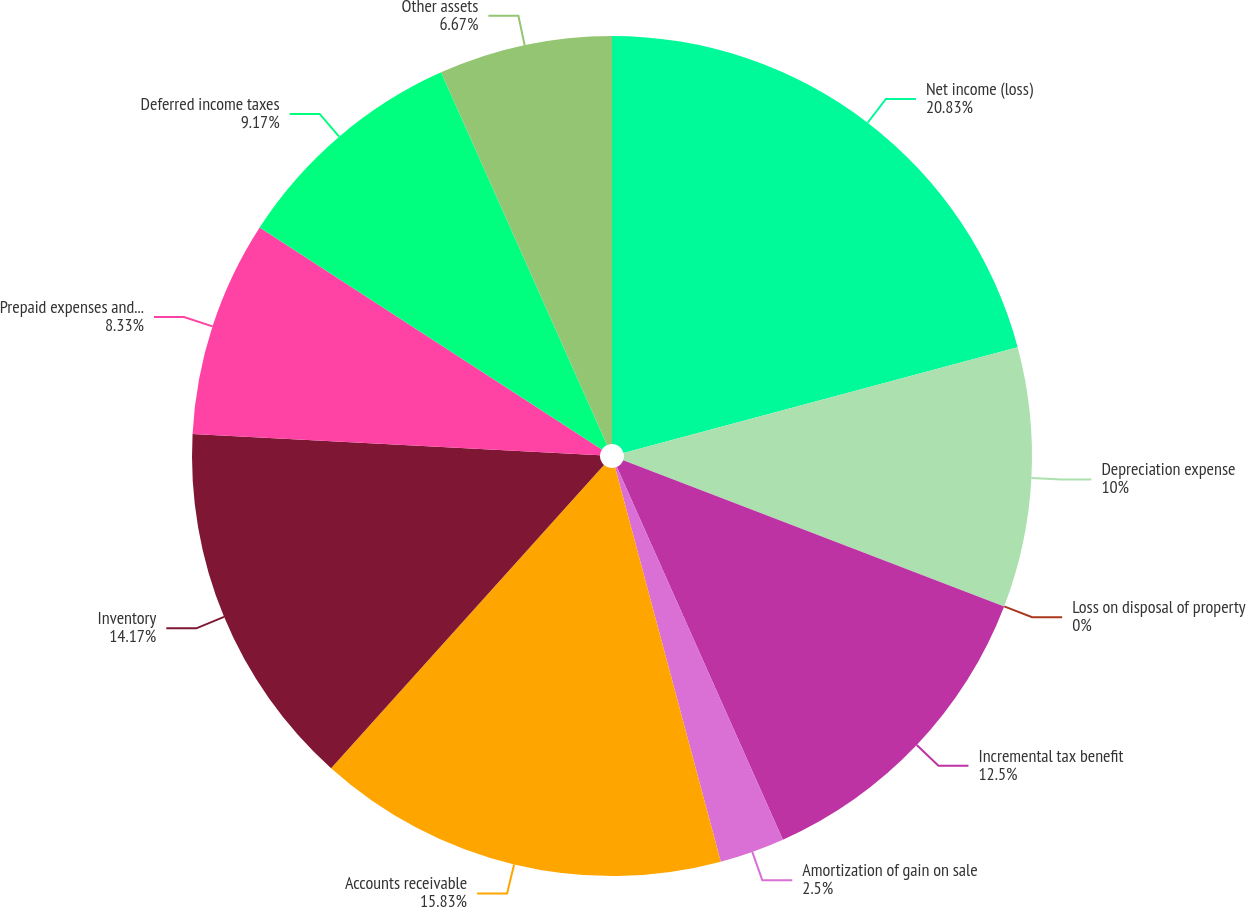Convert chart. <chart><loc_0><loc_0><loc_500><loc_500><pie_chart><fcel>Net income (loss)<fcel>Depreciation expense<fcel>Loss on disposal of property<fcel>Incremental tax benefit<fcel>Amortization of gain on sale<fcel>Accounts receivable<fcel>Inventory<fcel>Prepaid expenses and other<fcel>Deferred income taxes<fcel>Other assets<nl><fcel>20.83%<fcel>10.0%<fcel>0.0%<fcel>12.5%<fcel>2.5%<fcel>15.83%<fcel>14.17%<fcel>8.33%<fcel>9.17%<fcel>6.67%<nl></chart> 